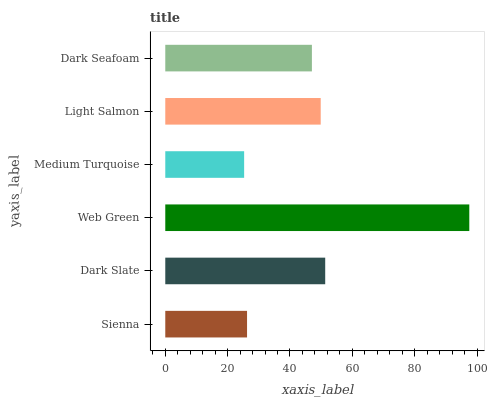Is Medium Turquoise the minimum?
Answer yes or no. Yes. Is Web Green the maximum?
Answer yes or no. Yes. Is Dark Slate the minimum?
Answer yes or no. No. Is Dark Slate the maximum?
Answer yes or no. No. Is Dark Slate greater than Sienna?
Answer yes or no. Yes. Is Sienna less than Dark Slate?
Answer yes or no. Yes. Is Sienna greater than Dark Slate?
Answer yes or no. No. Is Dark Slate less than Sienna?
Answer yes or no. No. Is Light Salmon the high median?
Answer yes or no. Yes. Is Dark Seafoam the low median?
Answer yes or no. Yes. Is Sienna the high median?
Answer yes or no. No. Is Medium Turquoise the low median?
Answer yes or no. No. 